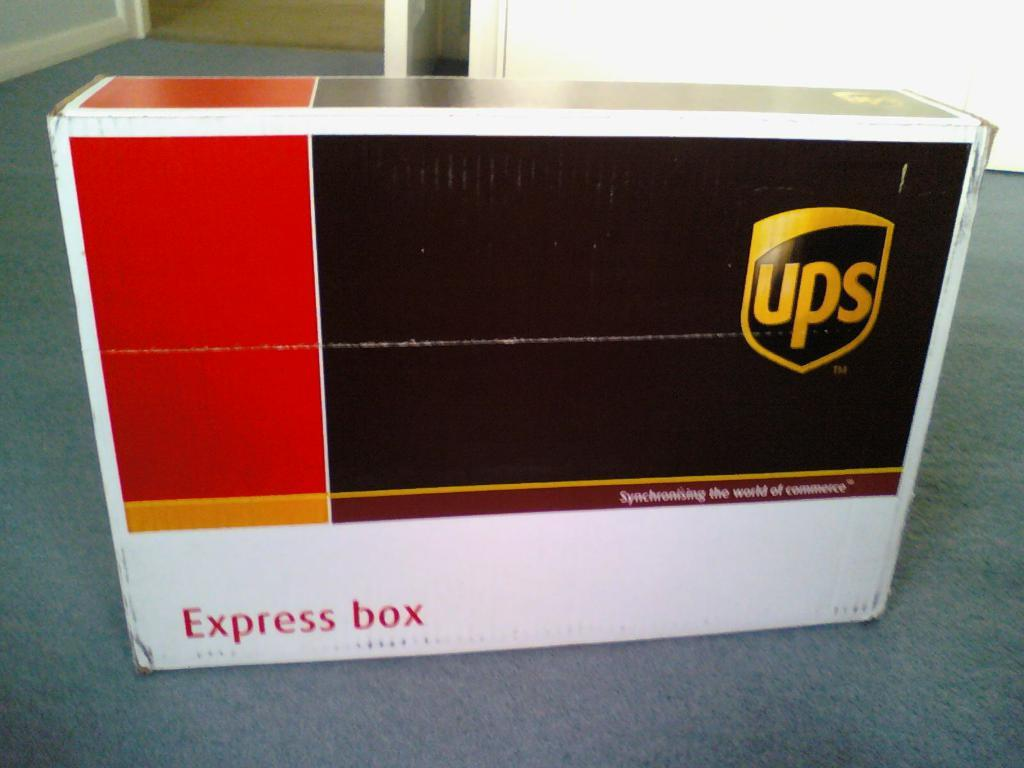<image>
Render a clear and concise summary of the photo. A UPS express box lays on the floor. 